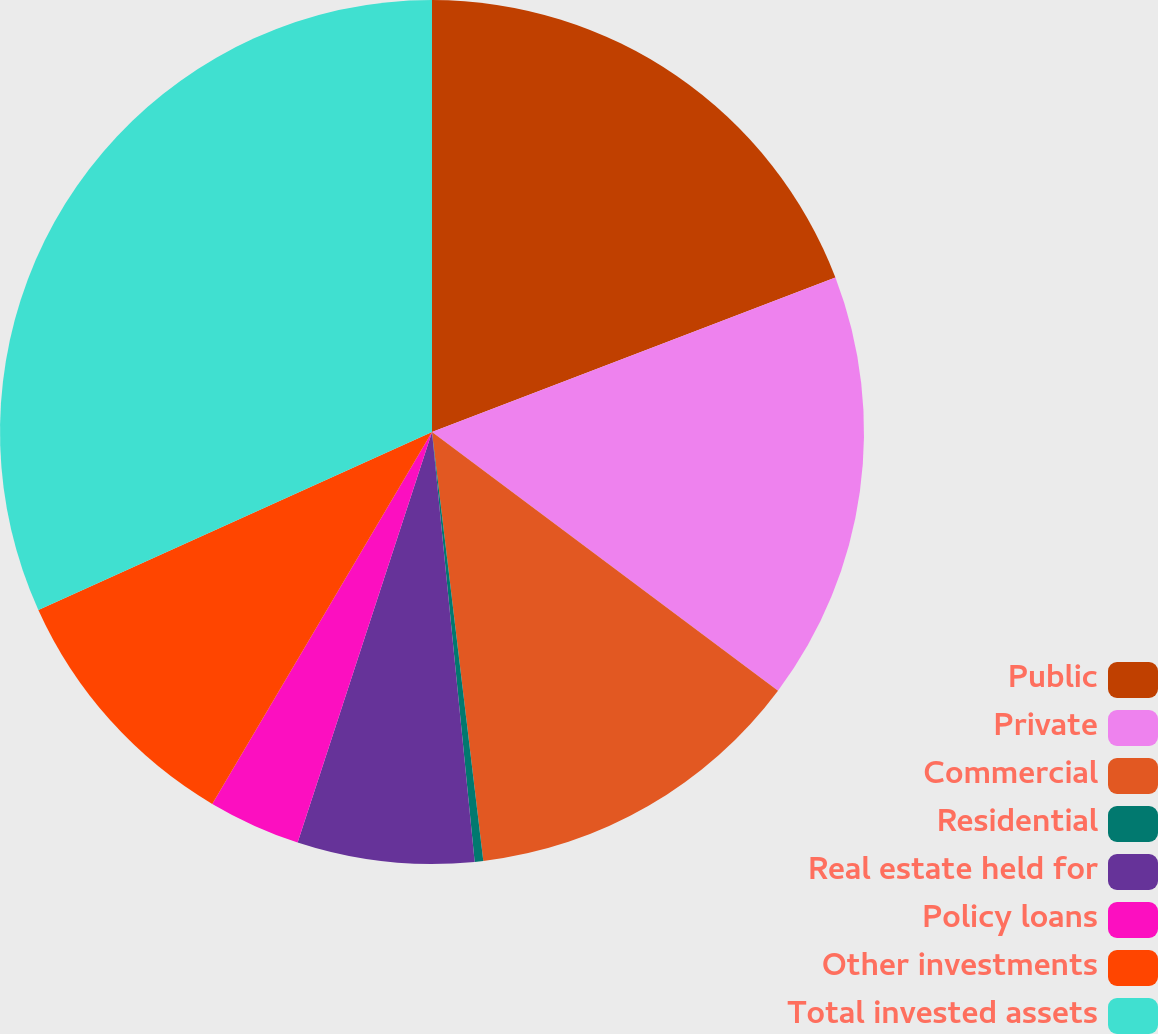Convert chart. <chart><loc_0><loc_0><loc_500><loc_500><pie_chart><fcel>Public<fcel>Private<fcel>Commercial<fcel>Residential<fcel>Real estate held for<fcel>Policy loans<fcel>Other investments<fcel>Total invested assets<nl><fcel>19.18%<fcel>16.04%<fcel>12.89%<fcel>0.32%<fcel>6.61%<fcel>3.46%<fcel>9.75%<fcel>31.76%<nl></chart> 